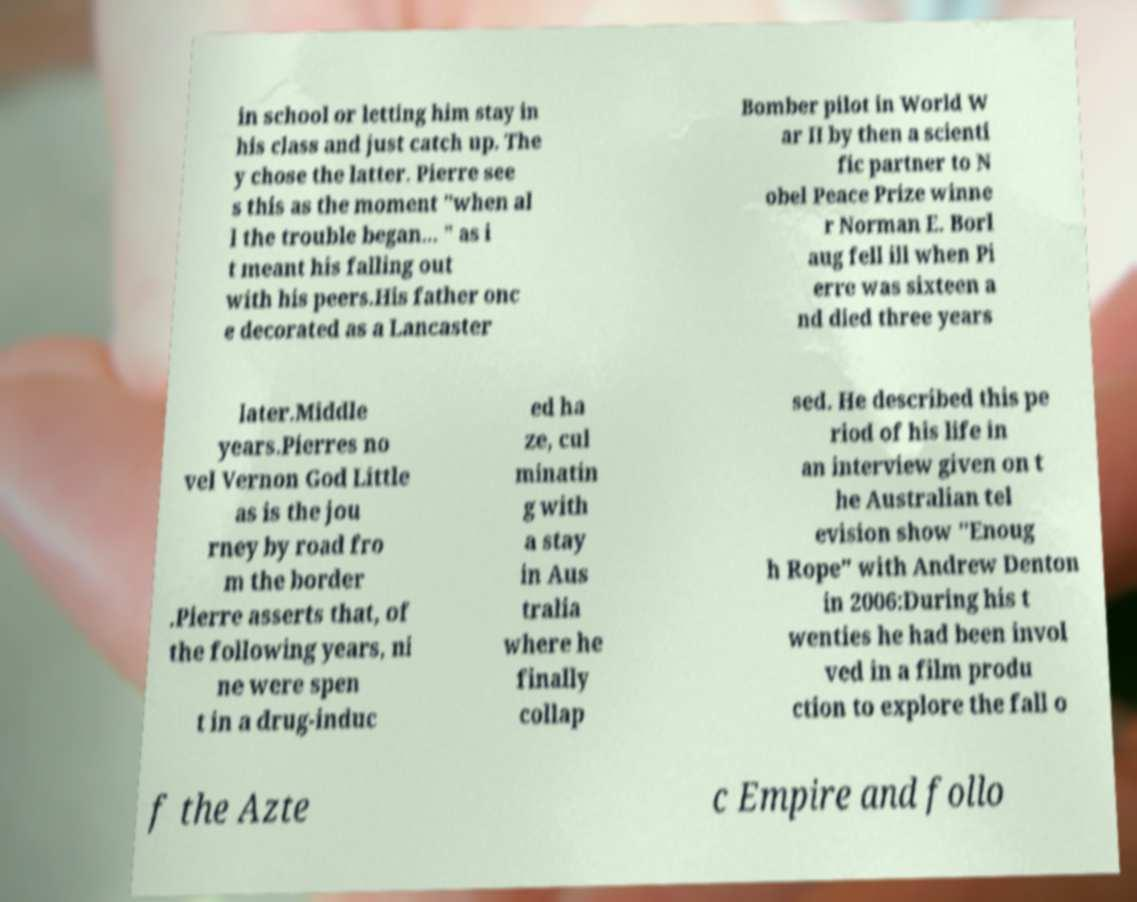Can you read and provide the text displayed in the image?This photo seems to have some interesting text. Can you extract and type it out for me? in school or letting him stay in his class and just catch up. The y chose the latter. Pierre see s this as the moment "when al l the trouble began... " as i t meant his falling out with his peers.His father onc e decorated as a Lancaster Bomber pilot in World W ar II by then a scienti fic partner to N obel Peace Prize winne r Norman E. Borl aug fell ill when Pi erre was sixteen a nd died three years later.Middle years.Pierres no vel Vernon God Little as is the jou rney by road fro m the border .Pierre asserts that, of the following years, ni ne were spen t in a drug-induc ed ha ze, cul minatin g with a stay in Aus tralia where he finally collap sed. He described this pe riod of his life in an interview given on t he Australian tel evision show "Enoug h Rope" with Andrew Denton in 2006:During his t wenties he had been invol ved in a film produ ction to explore the fall o f the Azte c Empire and follo 